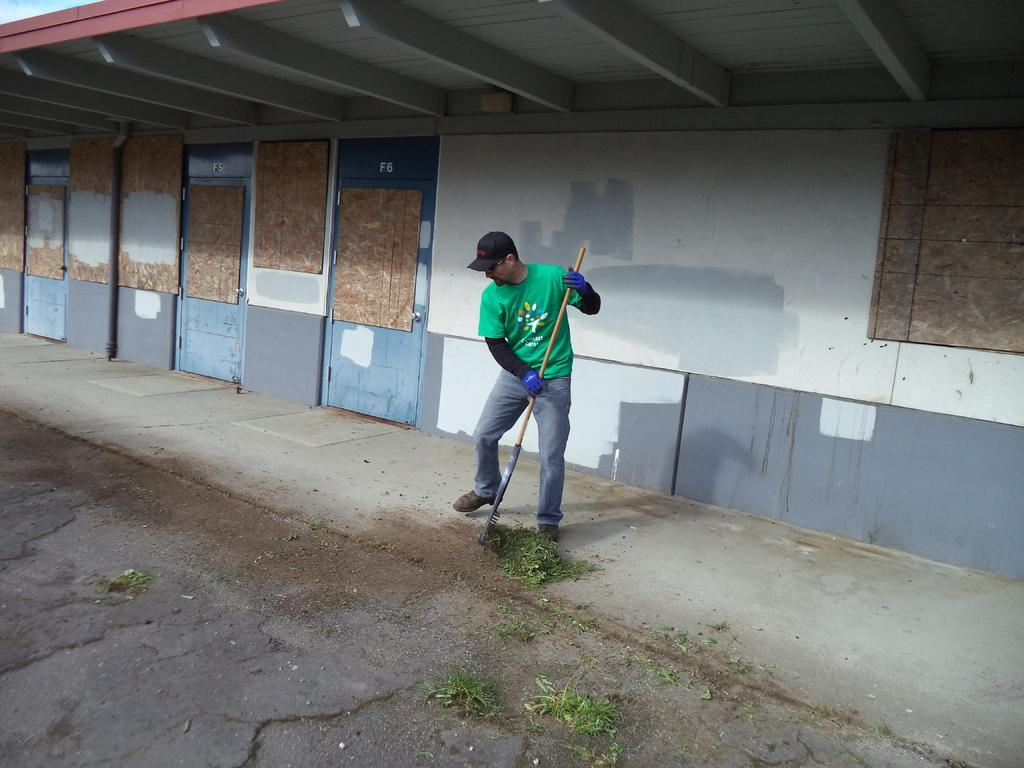What is the main structure visible in the image? There is a building wall in the image. What can be seen in front of the building wall? There are three doors in front of the building wall. What is the man in the image doing? The man is cleaning the path with a stick. What is the man wearing on his upper body? The man is wearing a green T-shirt. What protective gear is the man wearing on his hands? The man is wearing gloves. What headgear is the man wearing? The man is wearing a cap. What type of gold jewelry is the man wearing in the image? There is no gold jewelry visible on the man in the image. Is the man in the image walking on the moon? No, the man is not in space; he is cleaning a path on Earth. 